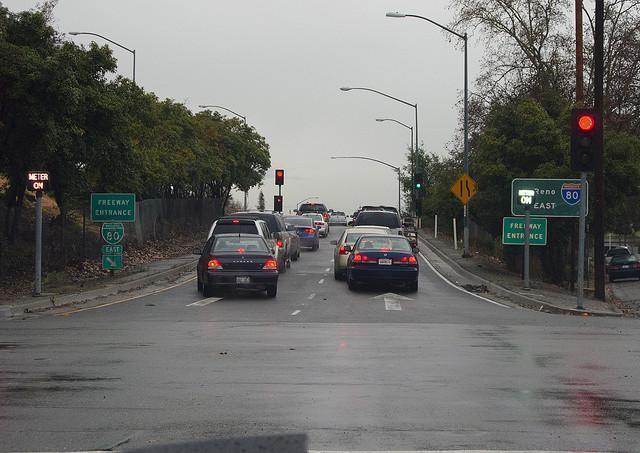How many cars are in the picture?
Give a very brief answer. 2. 